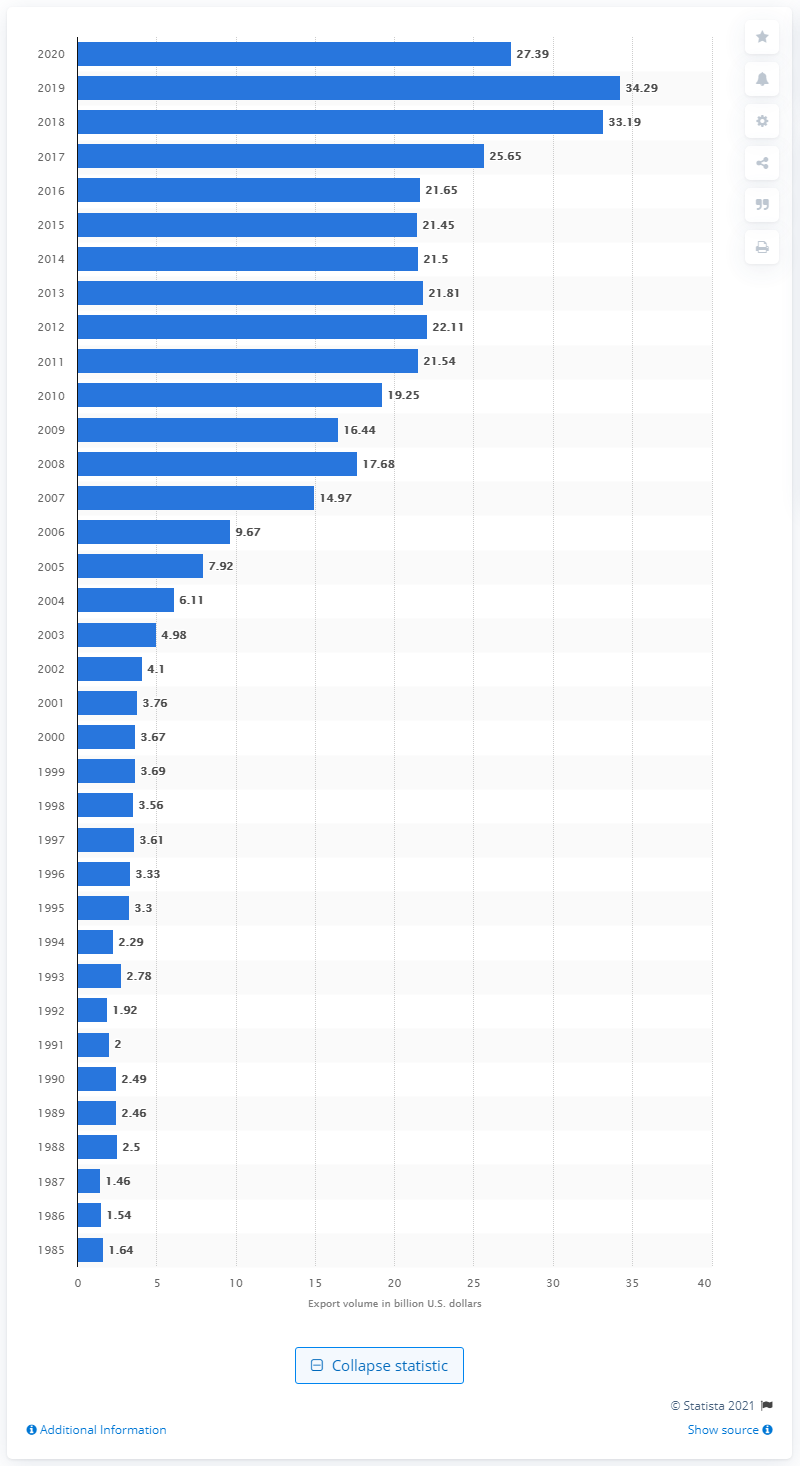Outline some significant characteristics in this image. The United States exported 27.39 billion dollars to India in 2020. 